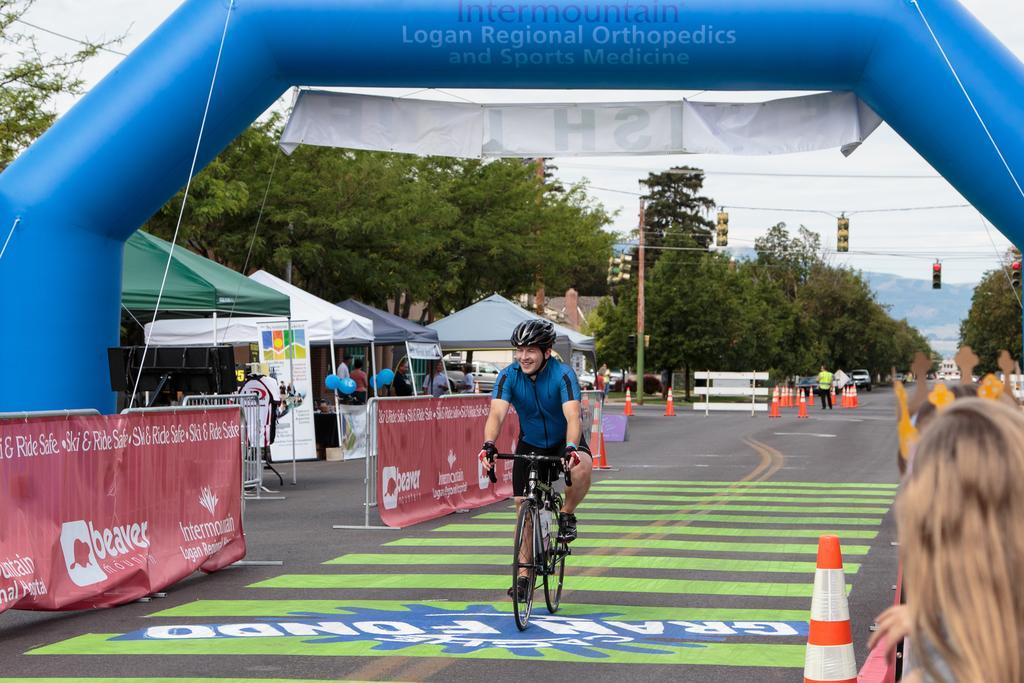Describe this image in one or two sentences. In this image we can see a man is cycling on the road. Background of the image stalls, poles, wires and trees are there. Left side of the image barriers are there. At the top of the image blue color thing is there with one banner. Right bottom of the image one person is there and we can see orange color road dividers. 